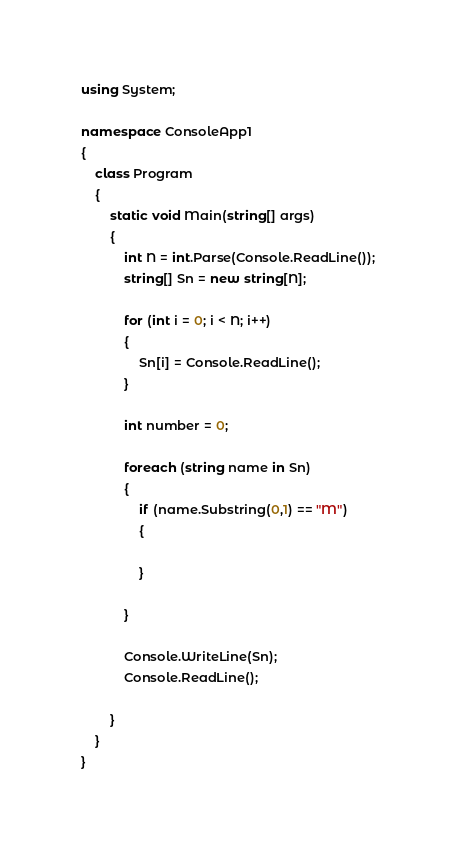Convert code to text. <code><loc_0><loc_0><loc_500><loc_500><_C#_>using System;

namespace ConsoleApp1
{
    class Program
    {
        static void Main(string[] args)
        {
            int N = int.Parse(Console.ReadLine());
            string[] Sn = new string[N];

            for (int i = 0; i < N; i++)
            {
                Sn[i] = Console.ReadLine();
            }

            int number = 0;

            foreach (string name in Sn)
            {
                if (name.Substring(0,1) == "M")
                {

                }

            }

            Console.WriteLine(Sn);
            Console.ReadLine();

        }
    }
}</code> 